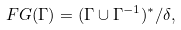Convert formula to latex. <formula><loc_0><loc_0><loc_500><loc_500>\ F G ( \Gamma ) = ( \Gamma \cup \Gamma ^ { - 1 } ) ^ { * } / \delta ,</formula> 